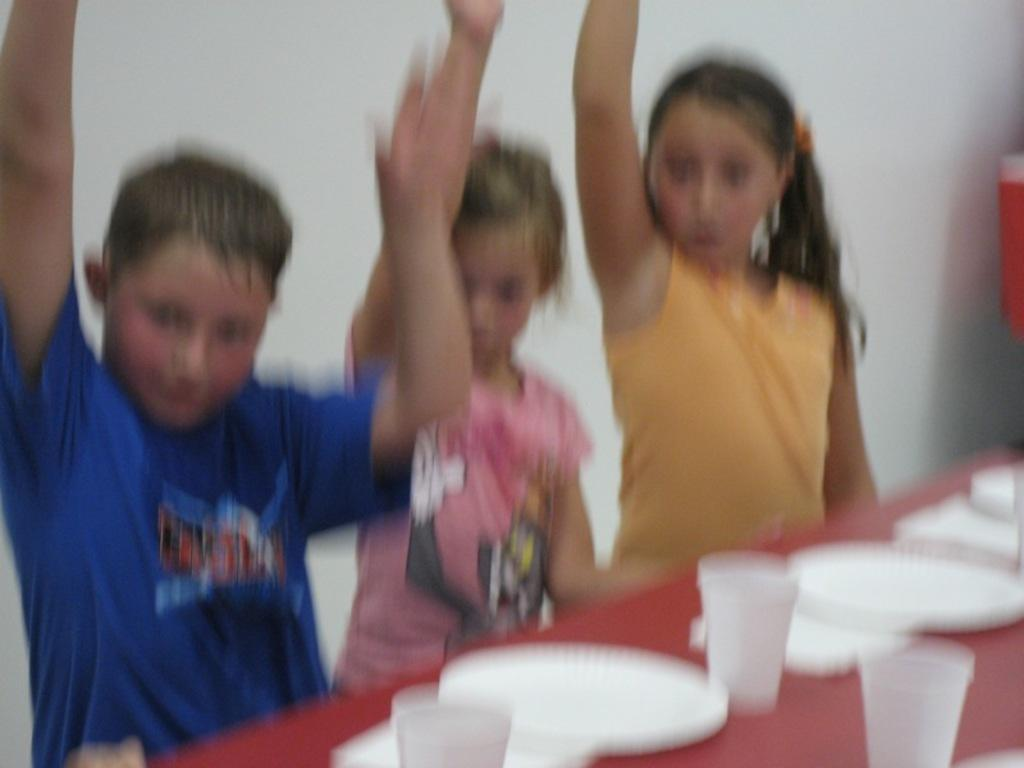How many people are in the image? There is a group of people in the image, but the exact number is not specified. What are the people doing in the image? The people are standing behind a table. What items can be seen on the table? There are plates and glasses on the table. What is visible in the background of the image? There is a wall visible in the image. What object is present in the image? There is an object in the image, but its description is not provided. What type of lettuce can be seen growing on the trail in the image? There is no trail or lettuce present in the image. 